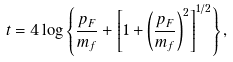Convert formula to latex. <formula><loc_0><loc_0><loc_500><loc_500>t = 4 \log \left \{ \frac { p _ { F } } { m _ { f } } + \left [ 1 + \left ( \frac { p _ { F } } { m _ { f } } \right ) ^ { 2 } \right ] ^ { 1 / 2 } \right \} ,</formula> 